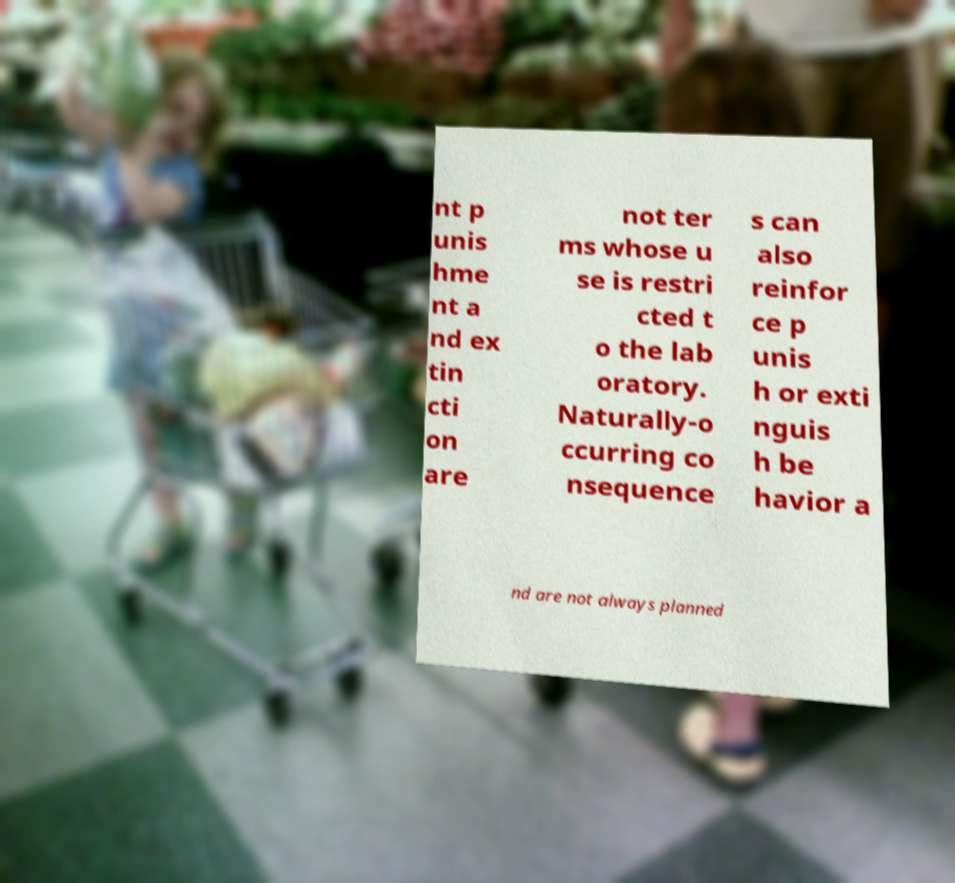There's text embedded in this image that I need extracted. Can you transcribe it verbatim? nt p unis hme nt a nd ex tin cti on are not ter ms whose u se is restri cted t o the lab oratory. Naturally-o ccurring co nsequence s can also reinfor ce p unis h or exti nguis h be havior a nd are not always planned 